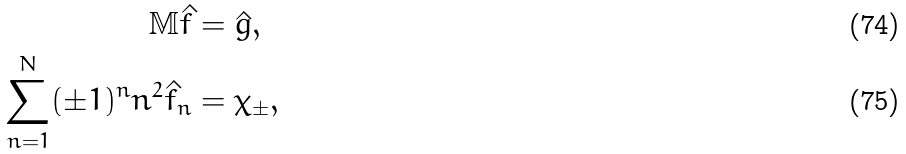Convert formula to latex. <formula><loc_0><loc_0><loc_500><loc_500>\mathbb { M } \hat { f } & = \hat { g } , \\ \sum _ { n = 1 } ^ { N } ( \pm 1 ) ^ { n } n ^ { 2 } \hat { f } _ { n } & = \chi _ { \pm } ,</formula> 